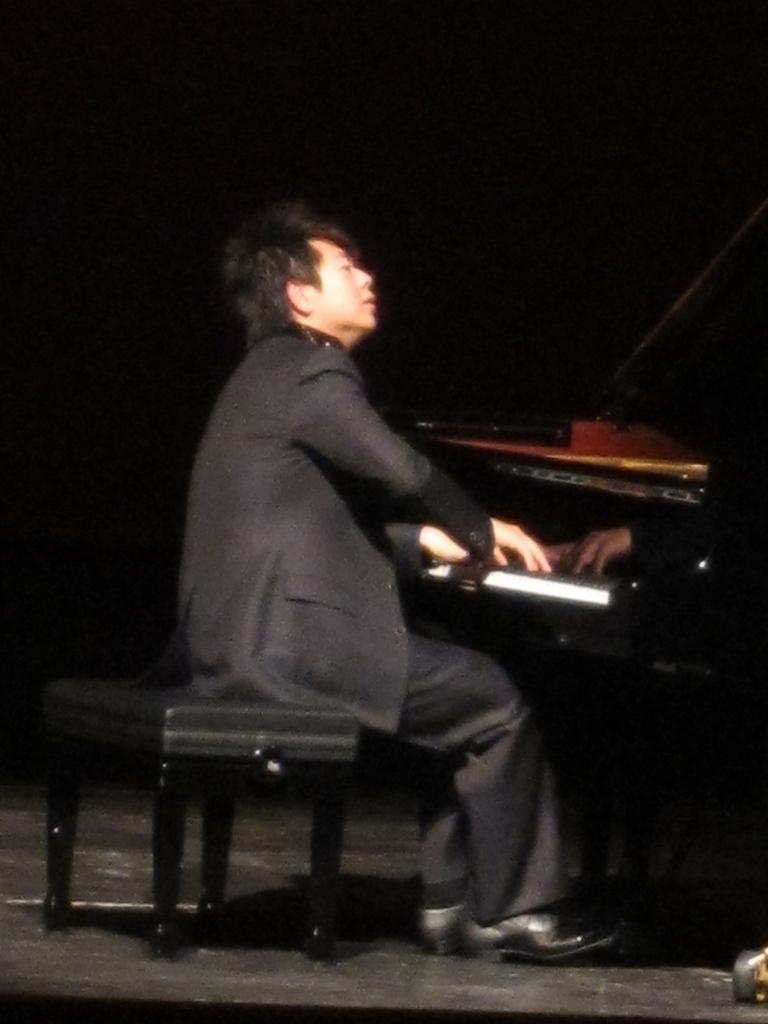Can you describe this image briefly? In this picture there is a man who is sitting on the stool at the center of the image and he is playing the piano which is placed at the right side of the image. 